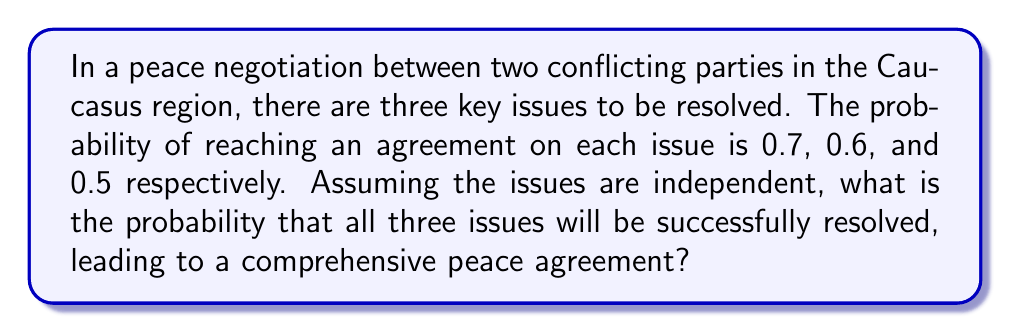Provide a solution to this math problem. Let's approach this step-by-step using basic probability theory:

1) We are dealing with independent events, where the success of one does not affect the others.

2) For independent events, the probability of all events occurring is the product of their individual probabilities.

3) Let's define our events:
   A: Agreement on first issue (P(A) = 0.7)
   B: Agreement on second issue (P(B) = 0.6)
   C: Agreement on third issue (P(C) = 0.5)

4) We want to find P(A and B and C)

5) For independent events: P(A and B and C) = P(A) × P(B) × P(C)

6) Substituting the values:
   P(A and B and C) = 0.7 × 0.6 × 0.5

7) Calculating:
   P(A and B and C) = 0.21

Therefore, the probability of successfully resolving all three issues and reaching a comprehensive peace agreement is 0.21 or 21%.
Answer: 0.21 